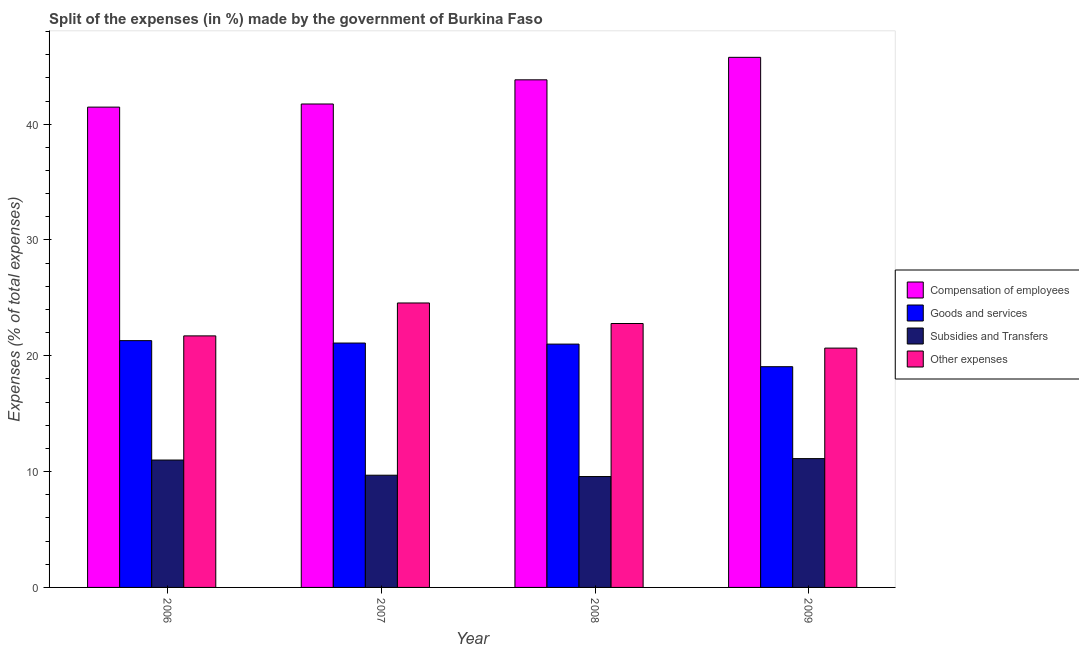Are the number of bars per tick equal to the number of legend labels?
Offer a very short reply. Yes. How many bars are there on the 1st tick from the left?
Your answer should be compact. 4. How many bars are there on the 1st tick from the right?
Your response must be concise. 4. What is the label of the 1st group of bars from the left?
Offer a terse response. 2006. In how many cases, is the number of bars for a given year not equal to the number of legend labels?
Give a very brief answer. 0. What is the percentage of amount spent on subsidies in 2007?
Offer a terse response. 9.69. Across all years, what is the maximum percentage of amount spent on other expenses?
Provide a short and direct response. 24.56. Across all years, what is the minimum percentage of amount spent on other expenses?
Offer a terse response. 20.66. In which year was the percentage of amount spent on compensation of employees maximum?
Offer a very short reply. 2009. What is the total percentage of amount spent on subsidies in the graph?
Make the answer very short. 41.39. What is the difference between the percentage of amount spent on compensation of employees in 2006 and that in 2008?
Offer a terse response. -2.36. What is the difference between the percentage of amount spent on compensation of employees in 2008 and the percentage of amount spent on other expenses in 2009?
Give a very brief answer. -1.94. What is the average percentage of amount spent on compensation of employees per year?
Make the answer very short. 43.2. In the year 2009, what is the difference between the percentage of amount spent on subsidies and percentage of amount spent on compensation of employees?
Keep it short and to the point. 0. In how many years, is the percentage of amount spent on subsidies greater than 28 %?
Provide a succinct answer. 0. What is the ratio of the percentage of amount spent on subsidies in 2008 to that in 2009?
Ensure brevity in your answer.  0.86. Is the percentage of amount spent on subsidies in 2006 less than that in 2008?
Make the answer very short. No. What is the difference between the highest and the second highest percentage of amount spent on other expenses?
Provide a short and direct response. 1.77. What is the difference between the highest and the lowest percentage of amount spent on other expenses?
Offer a terse response. 3.9. Is the sum of the percentage of amount spent on other expenses in 2006 and 2007 greater than the maximum percentage of amount spent on compensation of employees across all years?
Your response must be concise. Yes. What does the 4th bar from the left in 2008 represents?
Provide a succinct answer. Other expenses. What does the 2nd bar from the right in 2007 represents?
Your answer should be very brief. Subsidies and Transfers. Are all the bars in the graph horizontal?
Your answer should be compact. No. How many years are there in the graph?
Your answer should be compact. 4. Does the graph contain any zero values?
Provide a succinct answer. No. What is the title of the graph?
Offer a very short reply. Split of the expenses (in %) made by the government of Burkina Faso. Does "Other greenhouse gases" appear as one of the legend labels in the graph?
Keep it short and to the point. No. What is the label or title of the X-axis?
Give a very brief answer. Year. What is the label or title of the Y-axis?
Your answer should be very brief. Expenses (% of total expenses). What is the Expenses (% of total expenses) in Compensation of employees in 2006?
Your answer should be compact. 41.47. What is the Expenses (% of total expenses) of Goods and services in 2006?
Your response must be concise. 21.31. What is the Expenses (% of total expenses) of Subsidies and Transfers in 2006?
Ensure brevity in your answer.  11. What is the Expenses (% of total expenses) in Other expenses in 2006?
Ensure brevity in your answer.  21.72. What is the Expenses (% of total expenses) of Compensation of employees in 2007?
Provide a short and direct response. 41.74. What is the Expenses (% of total expenses) in Goods and services in 2007?
Ensure brevity in your answer.  21.1. What is the Expenses (% of total expenses) of Subsidies and Transfers in 2007?
Ensure brevity in your answer.  9.69. What is the Expenses (% of total expenses) in Other expenses in 2007?
Your answer should be very brief. 24.56. What is the Expenses (% of total expenses) in Compensation of employees in 2008?
Ensure brevity in your answer.  43.83. What is the Expenses (% of total expenses) in Goods and services in 2008?
Keep it short and to the point. 21.01. What is the Expenses (% of total expenses) in Subsidies and Transfers in 2008?
Offer a very short reply. 9.57. What is the Expenses (% of total expenses) of Other expenses in 2008?
Provide a succinct answer. 22.79. What is the Expenses (% of total expenses) of Compensation of employees in 2009?
Your answer should be very brief. 45.77. What is the Expenses (% of total expenses) in Goods and services in 2009?
Provide a succinct answer. 19.06. What is the Expenses (% of total expenses) in Subsidies and Transfers in 2009?
Make the answer very short. 11.12. What is the Expenses (% of total expenses) in Other expenses in 2009?
Provide a succinct answer. 20.66. Across all years, what is the maximum Expenses (% of total expenses) of Compensation of employees?
Make the answer very short. 45.77. Across all years, what is the maximum Expenses (% of total expenses) of Goods and services?
Provide a succinct answer. 21.31. Across all years, what is the maximum Expenses (% of total expenses) of Subsidies and Transfers?
Your answer should be compact. 11.12. Across all years, what is the maximum Expenses (% of total expenses) of Other expenses?
Your answer should be compact. 24.56. Across all years, what is the minimum Expenses (% of total expenses) in Compensation of employees?
Provide a short and direct response. 41.47. Across all years, what is the minimum Expenses (% of total expenses) in Goods and services?
Provide a short and direct response. 19.06. Across all years, what is the minimum Expenses (% of total expenses) in Subsidies and Transfers?
Provide a succinct answer. 9.57. Across all years, what is the minimum Expenses (% of total expenses) in Other expenses?
Your response must be concise. 20.66. What is the total Expenses (% of total expenses) of Compensation of employees in the graph?
Ensure brevity in your answer.  172.82. What is the total Expenses (% of total expenses) in Goods and services in the graph?
Ensure brevity in your answer.  82.48. What is the total Expenses (% of total expenses) in Subsidies and Transfers in the graph?
Ensure brevity in your answer.  41.39. What is the total Expenses (% of total expenses) in Other expenses in the graph?
Provide a short and direct response. 89.73. What is the difference between the Expenses (% of total expenses) in Compensation of employees in 2006 and that in 2007?
Provide a succinct answer. -0.27. What is the difference between the Expenses (% of total expenses) in Goods and services in 2006 and that in 2007?
Give a very brief answer. 0.21. What is the difference between the Expenses (% of total expenses) of Subsidies and Transfers in 2006 and that in 2007?
Your answer should be very brief. 1.31. What is the difference between the Expenses (% of total expenses) of Other expenses in 2006 and that in 2007?
Your answer should be very brief. -2.84. What is the difference between the Expenses (% of total expenses) of Compensation of employees in 2006 and that in 2008?
Your answer should be very brief. -2.36. What is the difference between the Expenses (% of total expenses) in Goods and services in 2006 and that in 2008?
Your answer should be very brief. 0.3. What is the difference between the Expenses (% of total expenses) in Subsidies and Transfers in 2006 and that in 2008?
Make the answer very short. 1.43. What is the difference between the Expenses (% of total expenses) in Other expenses in 2006 and that in 2008?
Your response must be concise. -1.07. What is the difference between the Expenses (% of total expenses) of Compensation of employees in 2006 and that in 2009?
Your answer should be compact. -4.3. What is the difference between the Expenses (% of total expenses) in Goods and services in 2006 and that in 2009?
Offer a terse response. 2.25. What is the difference between the Expenses (% of total expenses) in Subsidies and Transfers in 2006 and that in 2009?
Your answer should be compact. -0.12. What is the difference between the Expenses (% of total expenses) of Other expenses in 2006 and that in 2009?
Provide a succinct answer. 1.05. What is the difference between the Expenses (% of total expenses) of Compensation of employees in 2007 and that in 2008?
Offer a terse response. -2.09. What is the difference between the Expenses (% of total expenses) in Goods and services in 2007 and that in 2008?
Your answer should be compact. 0.09. What is the difference between the Expenses (% of total expenses) of Subsidies and Transfers in 2007 and that in 2008?
Offer a terse response. 0.11. What is the difference between the Expenses (% of total expenses) in Other expenses in 2007 and that in 2008?
Offer a terse response. 1.77. What is the difference between the Expenses (% of total expenses) in Compensation of employees in 2007 and that in 2009?
Provide a succinct answer. -4.03. What is the difference between the Expenses (% of total expenses) of Goods and services in 2007 and that in 2009?
Keep it short and to the point. 2.04. What is the difference between the Expenses (% of total expenses) of Subsidies and Transfers in 2007 and that in 2009?
Ensure brevity in your answer.  -1.43. What is the difference between the Expenses (% of total expenses) of Other expenses in 2007 and that in 2009?
Provide a short and direct response. 3.9. What is the difference between the Expenses (% of total expenses) in Compensation of employees in 2008 and that in 2009?
Your answer should be compact. -1.94. What is the difference between the Expenses (% of total expenses) of Goods and services in 2008 and that in 2009?
Keep it short and to the point. 1.95. What is the difference between the Expenses (% of total expenses) of Subsidies and Transfers in 2008 and that in 2009?
Keep it short and to the point. -1.55. What is the difference between the Expenses (% of total expenses) in Other expenses in 2008 and that in 2009?
Give a very brief answer. 2.12. What is the difference between the Expenses (% of total expenses) in Compensation of employees in 2006 and the Expenses (% of total expenses) in Goods and services in 2007?
Your answer should be very brief. 20.37. What is the difference between the Expenses (% of total expenses) in Compensation of employees in 2006 and the Expenses (% of total expenses) in Subsidies and Transfers in 2007?
Keep it short and to the point. 31.78. What is the difference between the Expenses (% of total expenses) of Compensation of employees in 2006 and the Expenses (% of total expenses) of Other expenses in 2007?
Make the answer very short. 16.91. What is the difference between the Expenses (% of total expenses) of Goods and services in 2006 and the Expenses (% of total expenses) of Subsidies and Transfers in 2007?
Your answer should be compact. 11.62. What is the difference between the Expenses (% of total expenses) in Goods and services in 2006 and the Expenses (% of total expenses) in Other expenses in 2007?
Your response must be concise. -3.25. What is the difference between the Expenses (% of total expenses) of Subsidies and Transfers in 2006 and the Expenses (% of total expenses) of Other expenses in 2007?
Your answer should be very brief. -13.56. What is the difference between the Expenses (% of total expenses) in Compensation of employees in 2006 and the Expenses (% of total expenses) in Goods and services in 2008?
Provide a short and direct response. 20.46. What is the difference between the Expenses (% of total expenses) of Compensation of employees in 2006 and the Expenses (% of total expenses) of Subsidies and Transfers in 2008?
Provide a short and direct response. 31.9. What is the difference between the Expenses (% of total expenses) in Compensation of employees in 2006 and the Expenses (% of total expenses) in Other expenses in 2008?
Keep it short and to the point. 18.68. What is the difference between the Expenses (% of total expenses) in Goods and services in 2006 and the Expenses (% of total expenses) in Subsidies and Transfers in 2008?
Offer a very short reply. 11.74. What is the difference between the Expenses (% of total expenses) in Goods and services in 2006 and the Expenses (% of total expenses) in Other expenses in 2008?
Give a very brief answer. -1.48. What is the difference between the Expenses (% of total expenses) of Subsidies and Transfers in 2006 and the Expenses (% of total expenses) of Other expenses in 2008?
Make the answer very short. -11.79. What is the difference between the Expenses (% of total expenses) of Compensation of employees in 2006 and the Expenses (% of total expenses) of Goods and services in 2009?
Your answer should be very brief. 22.41. What is the difference between the Expenses (% of total expenses) of Compensation of employees in 2006 and the Expenses (% of total expenses) of Subsidies and Transfers in 2009?
Offer a very short reply. 30.35. What is the difference between the Expenses (% of total expenses) of Compensation of employees in 2006 and the Expenses (% of total expenses) of Other expenses in 2009?
Provide a succinct answer. 20.81. What is the difference between the Expenses (% of total expenses) in Goods and services in 2006 and the Expenses (% of total expenses) in Subsidies and Transfers in 2009?
Keep it short and to the point. 10.19. What is the difference between the Expenses (% of total expenses) in Goods and services in 2006 and the Expenses (% of total expenses) in Other expenses in 2009?
Provide a short and direct response. 0.65. What is the difference between the Expenses (% of total expenses) in Subsidies and Transfers in 2006 and the Expenses (% of total expenses) in Other expenses in 2009?
Your answer should be very brief. -9.67. What is the difference between the Expenses (% of total expenses) of Compensation of employees in 2007 and the Expenses (% of total expenses) of Goods and services in 2008?
Make the answer very short. 20.73. What is the difference between the Expenses (% of total expenses) in Compensation of employees in 2007 and the Expenses (% of total expenses) in Subsidies and Transfers in 2008?
Your answer should be very brief. 32.17. What is the difference between the Expenses (% of total expenses) of Compensation of employees in 2007 and the Expenses (% of total expenses) of Other expenses in 2008?
Make the answer very short. 18.95. What is the difference between the Expenses (% of total expenses) of Goods and services in 2007 and the Expenses (% of total expenses) of Subsidies and Transfers in 2008?
Keep it short and to the point. 11.53. What is the difference between the Expenses (% of total expenses) in Goods and services in 2007 and the Expenses (% of total expenses) in Other expenses in 2008?
Offer a terse response. -1.69. What is the difference between the Expenses (% of total expenses) of Subsidies and Transfers in 2007 and the Expenses (% of total expenses) of Other expenses in 2008?
Give a very brief answer. -13.1. What is the difference between the Expenses (% of total expenses) of Compensation of employees in 2007 and the Expenses (% of total expenses) of Goods and services in 2009?
Your answer should be very brief. 22.68. What is the difference between the Expenses (% of total expenses) in Compensation of employees in 2007 and the Expenses (% of total expenses) in Subsidies and Transfers in 2009?
Provide a short and direct response. 30.62. What is the difference between the Expenses (% of total expenses) of Compensation of employees in 2007 and the Expenses (% of total expenses) of Other expenses in 2009?
Provide a succinct answer. 21.08. What is the difference between the Expenses (% of total expenses) of Goods and services in 2007 and the Expenses (% of total expenses) of Subsidies and Transfers in 2009?
Provide a short and direct response. 9.98. What is the difference between the Expenses (% of total expenses) of Goods and services in 2007 and the Expenses (% of total expenses) of Other expenses in 2009?
Give a very brief answer. 0.44. What is the difference between the Expenses (% of total expenses) of Subsidies and Transfers in 2007 and the Expenses (% of total expenses) of Other expenses in 2009?
Make the answer very short. -10.98. What is the difference between the Expenses (% of total expenses) in Compensation of employees in 2008 and the Expenses (% of total expenses) in Goods and services in 2009?
Offer a terse response. 24.77. What is the difference between the Expenses (% of total expenses) in Compensation of employees in 2008 and the Expenses (% of total expenses) in Subsidies and Transfers in 2009?
Provide a short and direct response. 32.71. What is the difference between the Expenses (% of total expenses) of Compensation of employees in 2008 and the Expenses (% of total expenses) of Other expenses in 2009?
Keep it short and to the point. 23.16. What is the difference between the Expenses (% of total expenses) of Goods and services in 2008 and the Expenses (% of total expenses) of Subsidies and Transfers in 2009?
Provide a succinct answer. 9.89. What is the difference between the Expenses (% of total expenses) of Goods and services in 2008 and the Expenses (% of total expenses) of Other expenses in 2009?
Ensure brevity in your answer.  0.35. What is the difference between the Expenses (% of total expenses) of Subsidies and Transfers in 2008 and the Expenses (% of total expenses) of Other expenses in 2009?
Give a very brief answer. -11.09. What is the average Expenses (% of total expenses) in Compensation of employees per year?
Offer a very short reply. 43.2. What is the average Expenses (% of total expenses) of Goods and services per year?
Give a very brief answer. 20.62. What is the average Expenses (% of total expenses) of Subsidies and Transfers per year?
Your response must be concise. 10.35. What is the average Expenses (% of total expenses) in Other expenses per year?
Make the answer very short. 22.43. In the year 2006, what is the difference between the Expenses (% of total expenses) in Compensation of employees and Expenses (% of total expenses) in Goods and services?
Make the answer very short. 20.16. In the year 2006, what is the difference between the Expenses (% of total expenses) in Compensation of employees and Expenses (% of total expenses) in Subsidies and Transfers?
Your answer should be very brief. 30.47. In the year 2006, what is the difference between the Expenses (% of total expenses) in Compensation of employees and Expenses (% of total expenses) in Other expenses?
Offer a very short reply. 19.75. In the year 2006, what is the difference between the Expenses (% of total expenses) of Goods and services and Expenses (% of total expenses) of Subsidies and Transfers?
Make the answer very short. 10.31. In the year 2006, what is the difference between the Expenses (% of total expenses) in Goods and services and Expenses (% of total expenses) in Other expenses?
Provide a succinct answer. -0.41. In the year 2006, what is the difference between the Expenses (% of total expenses) of Subsidies and Transfers and Expenses (% of total expenses) of Other expenses?
Your answer should be very brief. -10.72. In the year 2007, what is the difference between the Expenses (% of total expenses) in Compensation of employees and Expenses (% of total expenses) in Goods and services?
Provide a succinct answer. 20.64. In the year 2007, what is the difference between the Expenses (% of total expenses) of Compensation of employees and Expenses (% of total expenses) of Subsidies and Transfers?
Provide a short and direct response. 32.05. In the year 2007, what is the difference between the Expenses (% of total expenses) in Compensation of employees and Expenses (% of total expenses) in Other expenses?
Provide a succinct answer. 17.18. In the year 2007, what is the difference between the Expenses (% of total expenses) in Goods and services and Expenses (% of total expenses) in Subsidies and Transfers?
Offer a very short reply. 11.41. In the year 2007, what is the difference between the Expenses (% of total expenses) of Goods and services and Expenses (% of total expenses) of Other expenses?
Make the answer very short. -3.46. In the year 2007, what is the difference between the Expenses (% of total expenses) in Subsidies and Transfers and Expenses (% of total expenses) in Other expenses?
Your answer should be compact. -14.87. In the year 2008, what is the difference between the Expenses (% of total expenses) of Compensation of employees and Expenses (% of total expenses) of Goods and services?
Make the answer very short. 22.82. In the year 2008, what is the difference between the Expenses (% of total expenses) of Compensation of employees and Expenses (% of total expenses) of Subsidies and Transfers?
Provide a short and direct response. 34.26. In the year 2008, what is the difference between the Expenses (% of total expenses) of Compensation of employees and Expenses (% of total expenses) of Other expenses?
Keep it short and to the point. 21.04. In the year 2008, what is the difference between the Expenses (% of total expenses) in Goods and services and Expenses (% of total expenses) in Subsidies and Transfers?
Ensure brevity in your answer.  11.44. In the year 2008, what is the difference between the Expenses (% of total expenses) of Goods and services and Expenses (% of total expenses) of Other expenses?
Offer a very short reply. -1.78. In the year 2008, what is the difference between the Expenses (% of total expenses) in Subsidies and Transfers and Expenses (% of total expenses) in Other expenses?
Provide a succinct answer. -13.21. In the year 2009, what is the difference between the Expenses (% of total expenses) of Compensation of employees and Expenses (% of total expenses) of Goods and services?
Your answer should be very brief. 26.71. In the year 2009, what is the difference between the Expenses (% of total expenses) of Compensation of employees and Expenses (% of total expenses) of Subsidies and Transfers?
Provide a succinct answer. 34.65. In the year 2009, what is the difference between the Expenses (% of total expenses) in Compensation of employees and Expenses (% of total expenses) in Other expenses?
Make the answer very short. 25.11. In the year 2009, what is the difference between the Expenses (% of total expenses) in Goods and services and Expenses (% of total expenses) in Subsidies and Transfers?
Give a very brief answer. 7.94. In the year 2009, what is the difference between the Expenses (% of total expenses) of Goods and services and Expenses (% of total expenses) of Other expenses?
Keep it short and to the point. -1.61. In the year 2009, what is the difference between the Expenses (% of total expenses) of Subsidies and Transfers and Expenses (% of total expenses) of Other expenses?
Provide a short and direct response. -9.54. What is the ratio of the Expenses (% of total expenses) of Goods and services in 2006 to that in 2007?
Provide a short and direct response. 1.01. What is the ratio of the Expenses (% of total expenses) of Subsidies and Transfers in 2006 to that in 2007?
Make the answer very short. 1.14. What is the ratio of the Expenses (% of total expenses) in Other expenses in 2006 to that in 2007?
Offer a terse response. 0.88. What is the ratio of the Expenses (% of total expenses) in Compensation of employees in 2006 to that in 2008?
Your answer should be compact. 0.95. What is the ratio of the Expenses (% of total expenses) in Goods and services in 2006 to that in 2008?
Give a very brief answer. 1.01. What is the ratio of the Expenses (% of total expenses) in Subsidies and Transfers in 2006 to that in 2008?
Make the answer very short. 1.15. What is the ratio of the Expenses (% of total expenses) of Other expenses in 2006 to that in 2008?
Make the answer very short. 0.95. What is the ratio of the Expenses (% of total expenses) in Compensation of employees in 2006 to that in 2009?
Offer a very short reply. 0.91. What is the ratio of the Expenses (% of total expenses) in Goods and services in 2006 to that in 2009?
Your answer should be compact. 1.12. What is the ratio of the Expenses (% of total expenses) of Subsidies and Transfers in 2006 to that in 2009?
Your response must be concise. 0.99. What is the ratio of the Expenses (% of total expenses) of Other expenses in 2006 to that in 2009?
Give a very brief answer. 1.05. What is the ratio of the Expenses (% of total expenses) of Goods and services in 2007 to that in 2008?
Give a very brief answer. 1. What is the ratio of the Expenses (% of total expenses) of Other expenses in 2007 to that in 2008?
Provide a succinct answer. 1.08. What is the ratio of the Expenses (% of total expenses) of Compensation of employees in 2007 to that in 2009?
Provide a succinct answer. 0.91. What is the ratio of the Expenses (% of total expenses) in Goods and services in 2007 to that in 2009?
Keep it short and to the point. 1.11. What is the ratio of the Expenses (% of total expenses) of Subsidies and Transfers in 2007 to that in 2009?
Offer a very short reply. 0.87. What is the ratio of the Expenses (% of total expenses) of Other expenses in 2007 to that in 2009?
Your answer should be very brief. 1.19. What is the ratio of the Expenses (% of total expenses) in Compensation of employees in 2008 to that in 2009?
Offer a very short reply. 0.96. What is the ratio of the Expenses (% of total expenses) of Goods and services in 2008 to that in 2009?
Give a very brief answer. 1.1. What is the ratio of the Expenses (% of total expenses) in Subsidies and Transfers in 2008 to that in 2009?
Make the answer very short. 0.86. What is the ratio of the Expenses (% of total expenses) of Other expenses in 2008 to that in 2009?
Ensure brevity in your answer.  1.1. What is the difference between the highest and the second highest Expenses (% of total expenses) of Compensation of employees?
Offer a very short reply. 1.94. What is the difference between the highest and the second highest Expenses (% of total expenses) of Goods and services?
Provide a short and direct response. 0.21. What is the difference between the highest and the second highest Expenses (% of total expenses) of Subsidies and Transfers?
Your response must be concise. 0.12. What is the difference between the highest and the second highest Expenses (% of total expenses) in Other expenses?
Keep it short and to the point. 1.77. What is the difference between the highest and the lowest Expenses (% of total expenses) of Compensation of employees?
Offer a very short reply. 4.3. What is the difference between the highest and the lowest Expenses (% of total expenses) of Goods and services?
Your response must be concise. 2.25. What is the difference between the highest and the lowest Expenses (% of total expenses) of Subsidies and Transfers?
Give a very brief answer. 1.55. What is the difference between the highest and the lowest Expenses (% of total expenses) of Other expenses?
Keep it short and to the point. 3.9. 